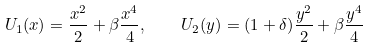<formula> <loc_0><loc_0><loc_500><loc_500>U _ { 1 } ( x ) = \frac { x ^ { 2 } } { 2 } + \beta \frac { x ^ { 4 } } { 4 } , \quad U _ { 2 } ( y ) = ( 1 + \delta ) \frac { y ^ { 2 } } { 2 } + \beta \frac { y ^ { 4 } } { 4 }</formula> 